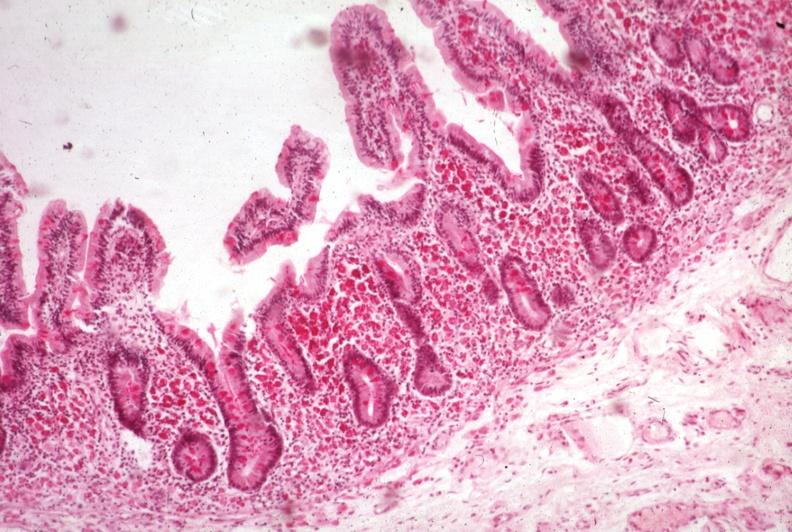s intestine present?
Answer the question using a single word or phrase. Yes 